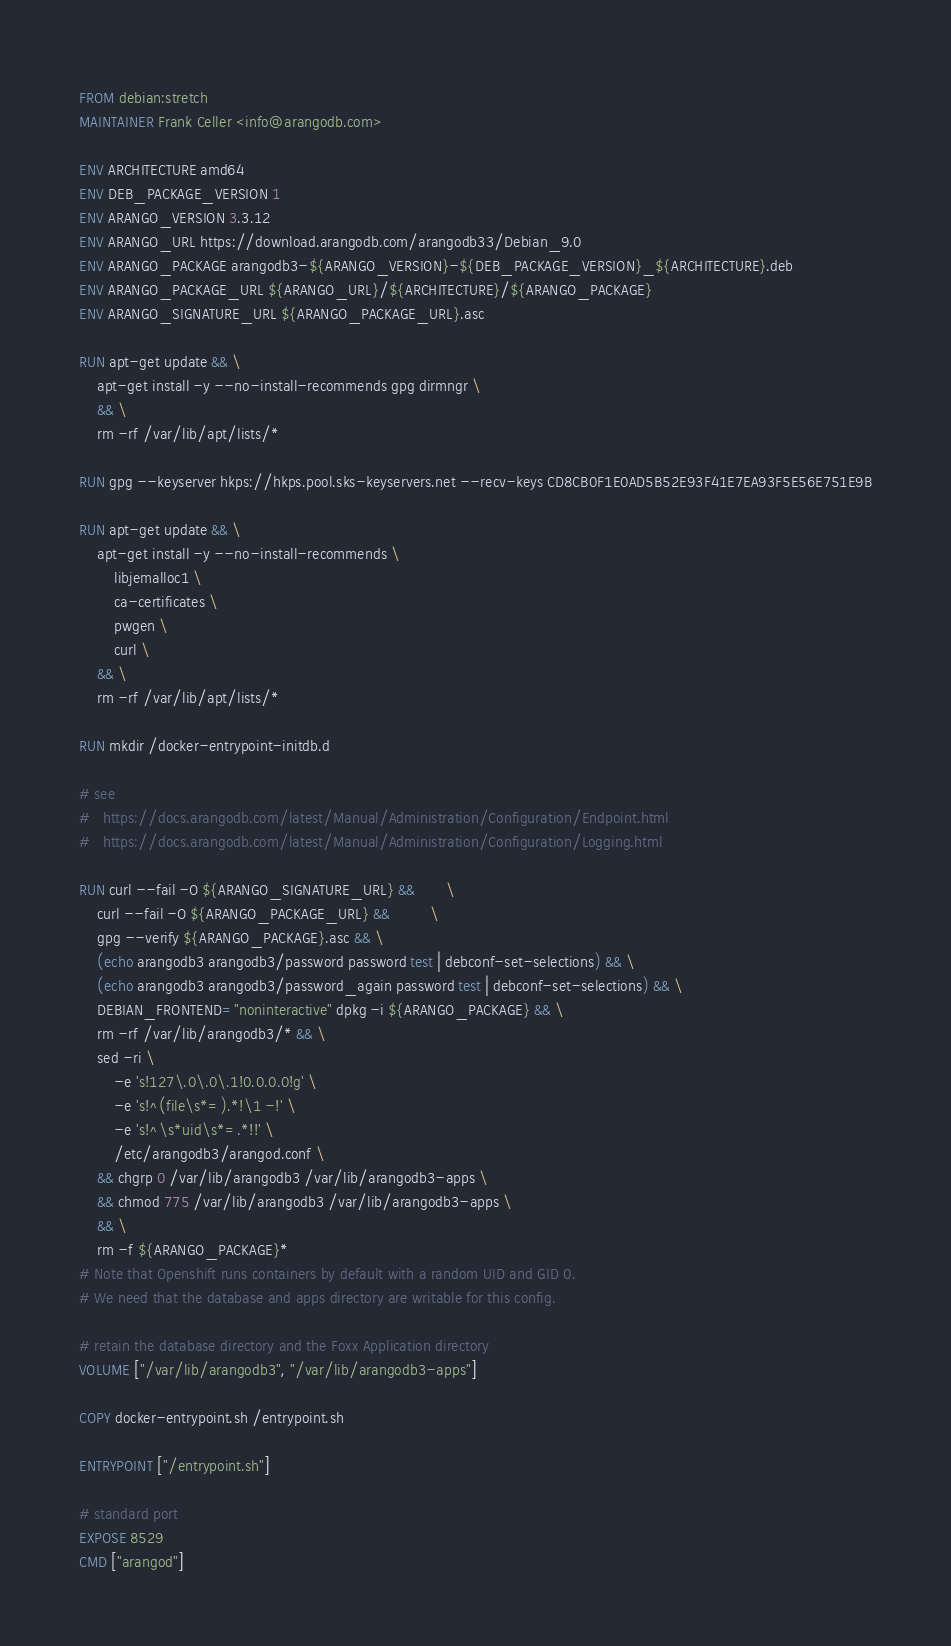Convert code to text. <code><loc_0><loc_0><loc_500><loc_500><_Dockerfile_>FROM debian:stretch
MAINTAINER Frank Celler <info@arangodb.com>

ENV ARCHITECTURE amd64
ENV DEB_PACKAGE_VERSION 1
ENV ARANGO_VERSION 3.3.12
ENV ARANGO_URL https://download.arangodb.com/arangodb33/Debian_9.0
ENV ARANGO_PACKAGE arangodb3-${ARANGO_VERSION}-${DEB_PACKAGE_VERSION}_${ARCHITECTURE}.deb
ENV ARANGO_PACKAGE_URL ${ARANGO_URL}/${ARCHITECTURE}/${ARANGO_PACKAGE}
ENV ARANGO_SIGNATURE_URL ${ARANGO_PACKAGE_URL}.asc

RUN apt-get update && \
    apt-get install -y --no-install-recommends gpg dirmngr \
    && \
    rm -rf /var/lib/apt/lists/*

RUN gpg --keyserver hkps://hkps.pool.sks-keyservers.net --recv-keys CD8CB0F1E0AD5B52E93F41E7EA93F5E56E751E9B

RUN apt-get update && \
    apt-get install -y --no-install-recommends \
        libjemalloc1 \
        ca-certificates \
        pwgen \
        curl \
    && \
    rm -rf /var/lib/apt/lists/*

RUN mkdir /docker-entrypoint-initdb.d

# see
#   https://docs.arangodb.com/latest/Manual/Administration/Configuration/Endpoint.html
#   https://docs.arangodb.com/latest/Manual/Administration/Configuration/Logging.html

RUN curl --fail -O ${ARANGO_SIGNATURE_URL} &&       \
    curl --fail -O ${ARANGO_PACKAGE_URL} &&         \
    gpg --verify ${ARANGO_PACKAGE}.asc && \
    (echo arangodb3 arangodb3/password password test | debconf-set-selections) && \
    (echo arangodb3 arangodb3/password_again password test | debconf-set-selections) && \
    DEBIAN_FRONTEND="noninteractive" dpkg -i ${ARANGO_PACKAGE} && \
    rm -rf /var/lib/arangodb3/* && \
    sed -ri \
        -e 's!127\.0\.0\.1!0.0.0.0!g' \
        -e 's!^(file\s*=).*!\1 -!' \
        -e 's!^\s*uid\s*=.*!!' \
        /etc/arangodb3/arangod.conf \
    && chgrp 0 /var/lib/arangodb3 /var/lib/arangodb3-apps \
    && chmod 775 /var/lib/arangodb3 /var/lib/arangodb3-apps \
    && \
    rm -f ${ARANGO_PACKAGE}*
# Note that Openshift runs containers by default with a random UID and GID 0.
# We need that the database and apps directory are writable for this config.

# retain the database directory and the Foxx Application directory
VOLUME ["/var/lib/arangodb3", "/var/lib/arangodb3-apps"]

COPY docker-entrypoint.sh /entrypoint.sh

ENTRYPOINT ["/entrypoint.sh"]

# standard port
EXPOSE 8529
CMD ["arangod"]
</code> 